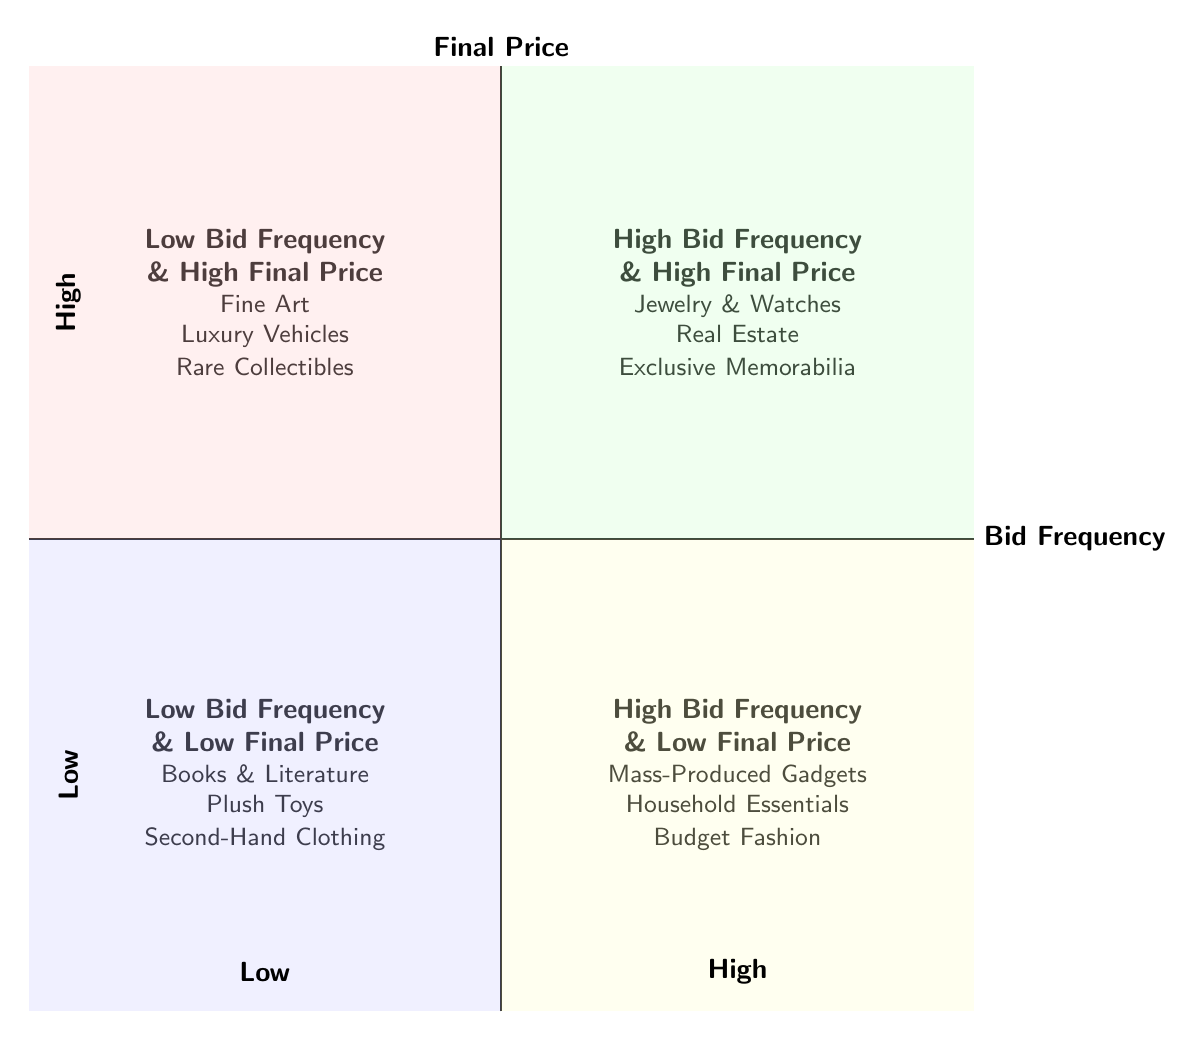What items fall into the "High Bid Frequency & Low Final Price" category? The diagram indicates that in the "High Bid Frequency & Low Final Price" quadrant, the items listed are "Mass-Produced Gadgets," "Household Essentials," and "Budget Fashion."
Answer: Mass-Produced Gadgets, Household Essentials, Budget Fashion Which quadrant represents categories with infrequent bids? The "Low Bid Frequency & High Final Price" quadrant depicts categories with infrequent bids as it is placed in the top left section of the diagram.
Answer: Low Bid Frequency & High Final Price How many categories are there in total? The diagram lists four distinct categories: Low Bid Frequency & High Final Price, High Bid Frequency & High Final Price, Low Bid Frequency & Low Final Price, and High Bid Frequency & Low Final Price, resulting in a total of four categories.
Answer: 4 What is the relationship between bid frequency and final price in the "High Bid Frequency & High Final Price" quadrant? This quadrant shows a positive relationship where items experience high bid frequency and high final prices, indicating competitive bidding that drives prices up.
Answer: Positive Which category contains items like "Fine Art"? As shown in the diagram, "Fine Art" is categorized under "Low Bid Frequency & High Final Price," reflecting its exclusivity and high final price despite fewer bids.
Answer: Low Bid Frequency & High Final Price What type of items are found in the "Low Bid Frequency & Low Final Price" quadrant? The items listed here include "Books & Literature," "Plush Toys," and "Second-Hand Clothing," which are often associated with lower demand and final prices.
Answer: Books & Literature, Plush Toys, Second-Hand Clothing Is "Real Estate" categorized under low or high bid frequency? According to the diagram, "Real Estate" is in the "High Bid Frequency & High Final Price" quadrant, indicating that it attracts significant bidding activity.
Answer: High Bid Frequency What differentiates the "High Bid Frequency & Low Final Price" from "High Bid Frequency & High Final Price"? The difference lies in pricing; the former settles at lower final prices despite high bidding activity, while the latter results in higher prices due to competitive bidding.
Answer: Pricing difference 